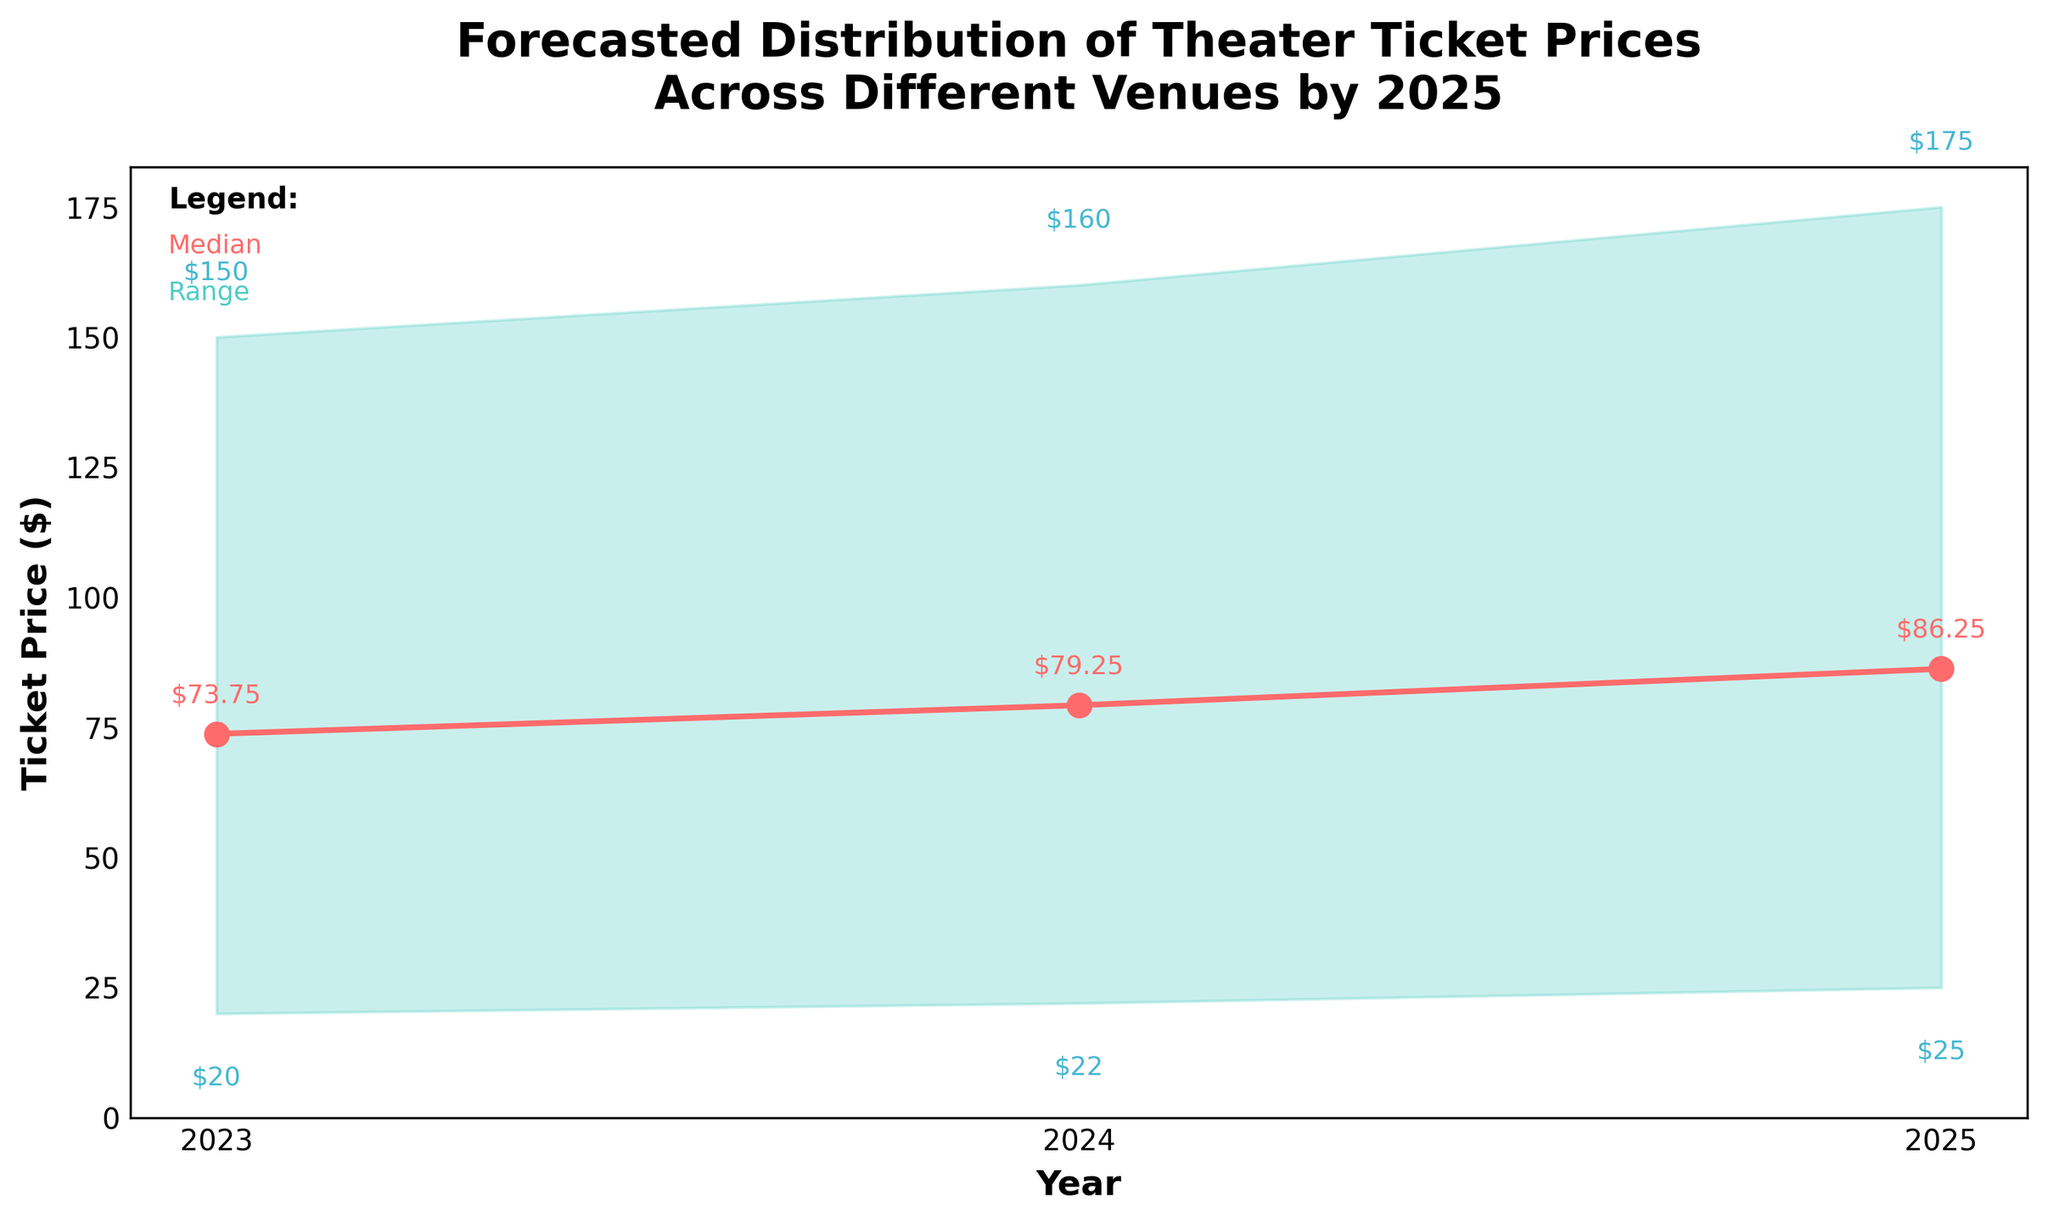Which year has the highest median ticket price? By looking at the median line on the plot, we can see that the ticket price rises each year. The highest median value is in 2025.
Answer: 2025 What is the lowest predicted ticket price in 2024? The lower bound of the fan chart for 2024 provides this information. The lowest ticket price is annotated below the fan area for 2024.
Answer: $22 How much does the median ticket price increase from 2023 to 2025? By comparing the median values for 2023 and 2025, the increase is the difference between these two values: 86.25 - 73.75.
Answer: $12.50 What are the predicted ranges of ticket prices in 2025? The fan chart's filled area provides the range, with the lower bound at $25 and the upper bound at $175.
Answer: $25 to $175 Which year shows the most significant spread between the lowest and highest ticket prices? By examining the range (difference between high and low values) in each year, the widest span is seen in the range between $25 to $175 in 2025.
Answer: 2025 What does the shaded area represent? The shaded area in the fan chart represents the predicted range of ticket prices, spanning from the lowest to the highest predicted values for each year.
Answer: Predicted range of ticket prices In which year did the lowest ticket price surpass $20? The figure shows ticket prices rising each year, and the lowest price surpasses $20 in 2024.
Answer: 2024 What trend can be observed in the median ticket price from 2023 to 2025? The median line in the plot indicates a steady upward trend in ticket prices from 2023 to 2025.
Answer: Increasing How does the increase in the highest predicted ticket price from 2023 to 2024 compare to the increase from 2024 to 2025? Comparing the differences: from 2023 to 2024, it's 160 - 150 = $10. From 2024 to 2025, it's 175 - 160 = $15. The increase is greater from 2024 to 2025.
Answer: $15 is greater than $10 